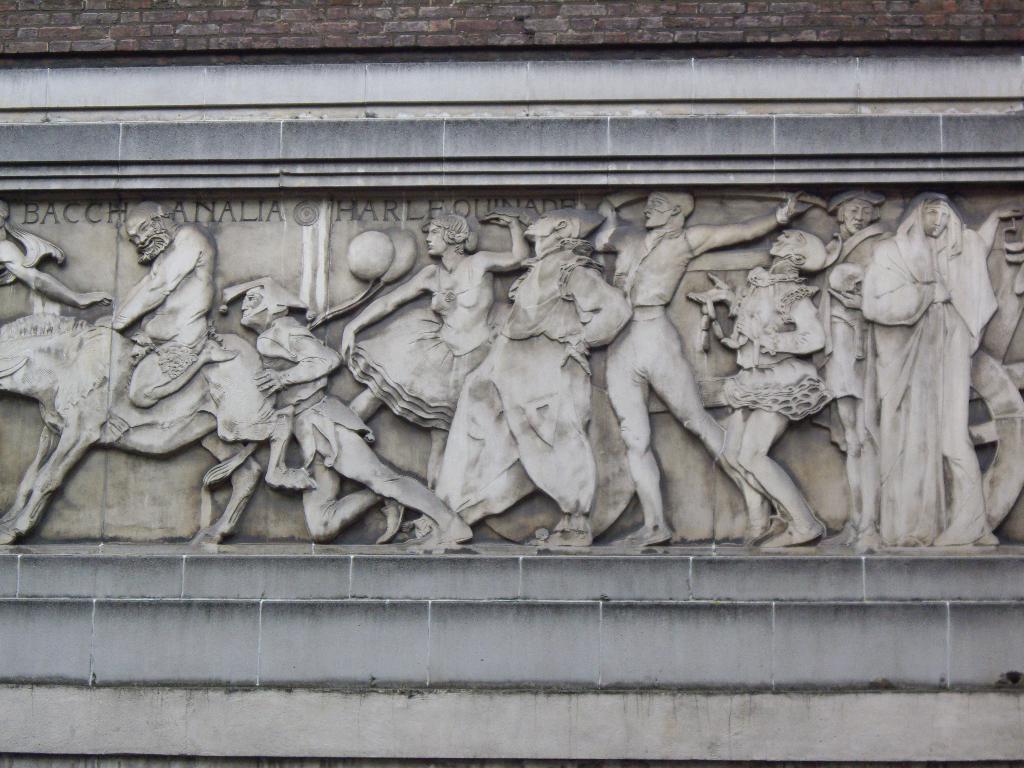Can you describe this image briefly? In this image, I can see the words and sculptures of people and an animal on the wall. 